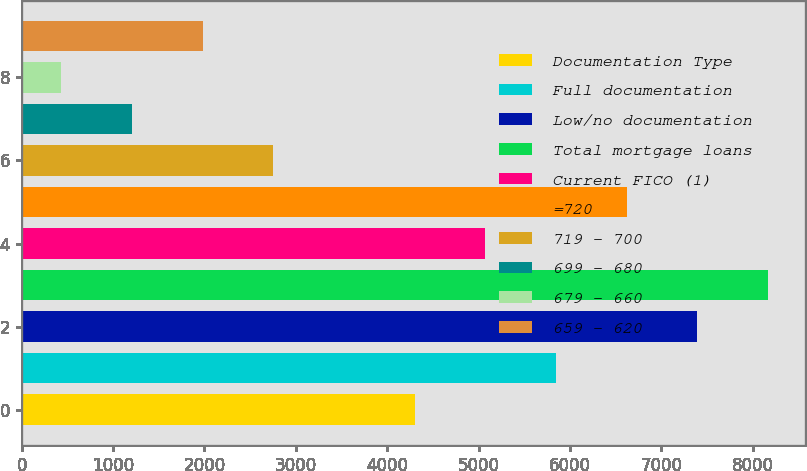<chart> <loc_0><loc_0><loc_500><loc_500><bar_chart><fcel>Documentation Type<fcel>Full documentation<fcel>Low/no documentation<fcel>Total mortgage loans<fcel>Current FICO (1)<fcel>=720<fcel>719 - 700<fcel>699 - 680<fcel>679 - 660<fcel>659 - 620<nl><fcel>4302.55<fcel>5849.65<fcel>7396.75<fcel>8170.3<fcel>5076.1<fcel>6623.2<fcel>2755.45<fcel>1208.35<fcel>434.8<fcel>1981.9<nl></chart> 